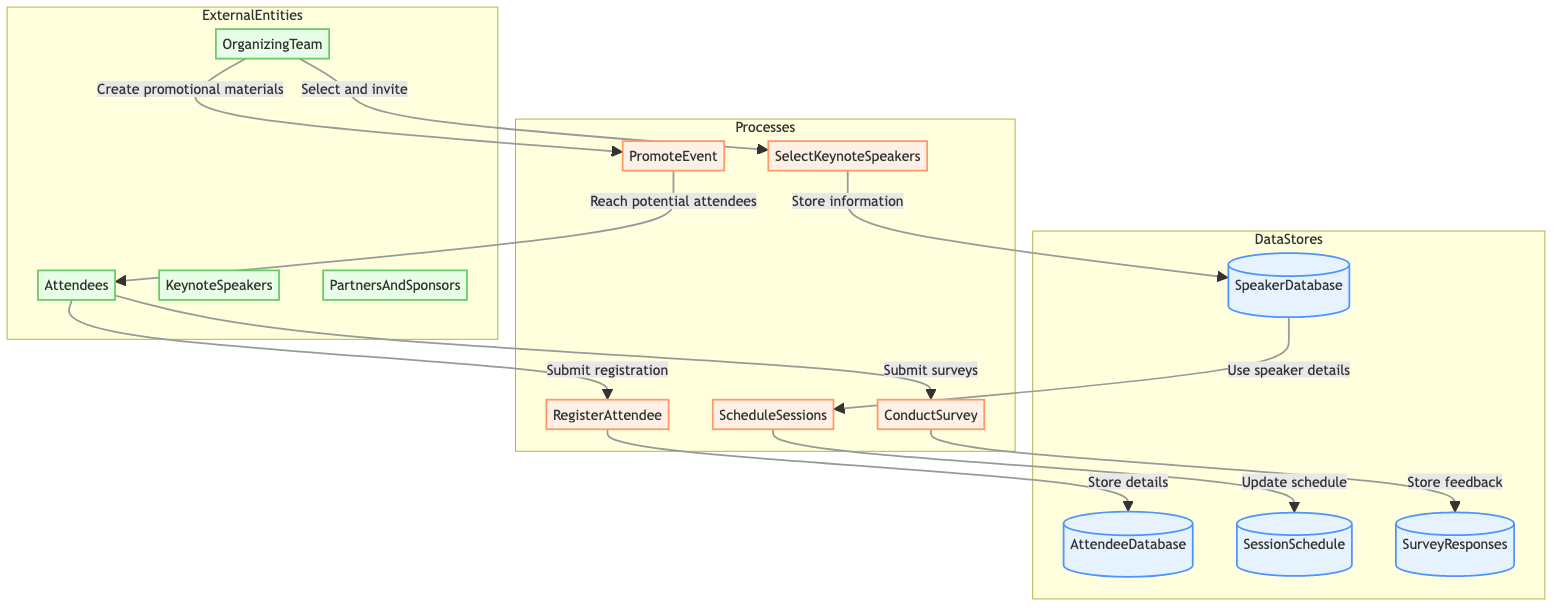What is the name of the process that captures attendee registration details? The diagram indicates that the process responsible for capturing registration details of attendees is called "RegisterAttendee." This can be directly observed in the processes section of the diagram.
Answer: RegisterAttendee How many data stores are present in the diagram? By examining the data stores section, we see there are four distinct data stores listed: AttendeeDatabase, SpeakerDatabase, SessionSchedule, and SurveyResponses. Therefore, the total count is four.
Answer: Four Which external entity submits the registration details? Looking at the data flow, it's clear that the external entity "Attendees" submits their registration details to the process "RegisterAttendee." This relationship is indicated by the directed arrow leading from Attendees to RegisterAttendee.
Answer: Attendees What is the outcome of the "ConductSurvey" process? The "ConductSurvey" process collects survey feedback from attendees and stores it in the "SurveyResponses" data store. The data flow leading out of "ConductSurvey" points directly to "SurveyResponses," indicating this storage function.
Answer: Store feedback Who creates promotional materials for the event? The diagram shows that the "OrganizingTeam" is responsible for creating promotional materials, as indicated by the data flow from the "OrganizingTeam" to the "PromoteEvent" process.
Answer: OrganizingTeam What is the relationship between the "SelectKeynoteSpeakers" process and the "SpeakerDatabase"? The connection is indicated by the directed flow from "SelectKeynoteSpeakers" to "SpeakerDatabase," meaning that the process stores information about the confirmed keynote speakers in this data store. This shows a storage relationship where speaker details are maintained.
Answer: Stores information How do attendees receive conference promotion materials? According to the data flow, the promotional materials and event announcements created by the "PromoteEvent" process reach the attendees directly, demonstrating a flow from "PromoteEvent" to "Attendees." This indicates the method of communication for event promotion.
Answer: Reach potential attendees Which process updates the session schedule? In examining the processes, "ScheduleSessions" is the designated process that updates the "SessionSchedule" data store, as indicated by the flow from "ScheduleSessions" to "SessionSchedule." This shows its role in managing the session timetable.
Answer: ScheduleSessions What type of feedback is collected by the "ConductSurvey"? The "ConductSurvey" process specifically collects post-event survey responses from attendees, as indicated by the flow from "Attendees" to "ConductSurvey." This describes the nature of feedback being gathered.
Answer: Survey responses 